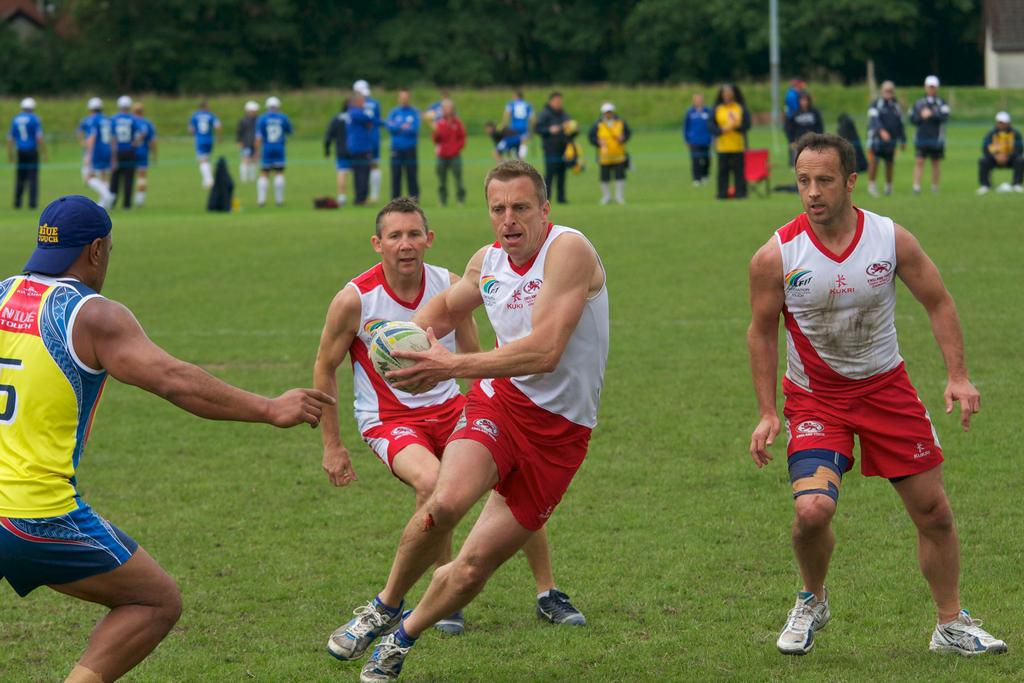What activity are the players engaged in within the image? The players are playing with a ball in the image. Can you describe the setting where the players are located? There is grass on the ground in the image, and there are trees visible in the background. Are there any other people present in the image besides the players? Yes, there are people standing in the background of the image. What type of treatment is being administered to the loaf in the image? There is no loaf present in the image, so no treatment can be administered to it. 